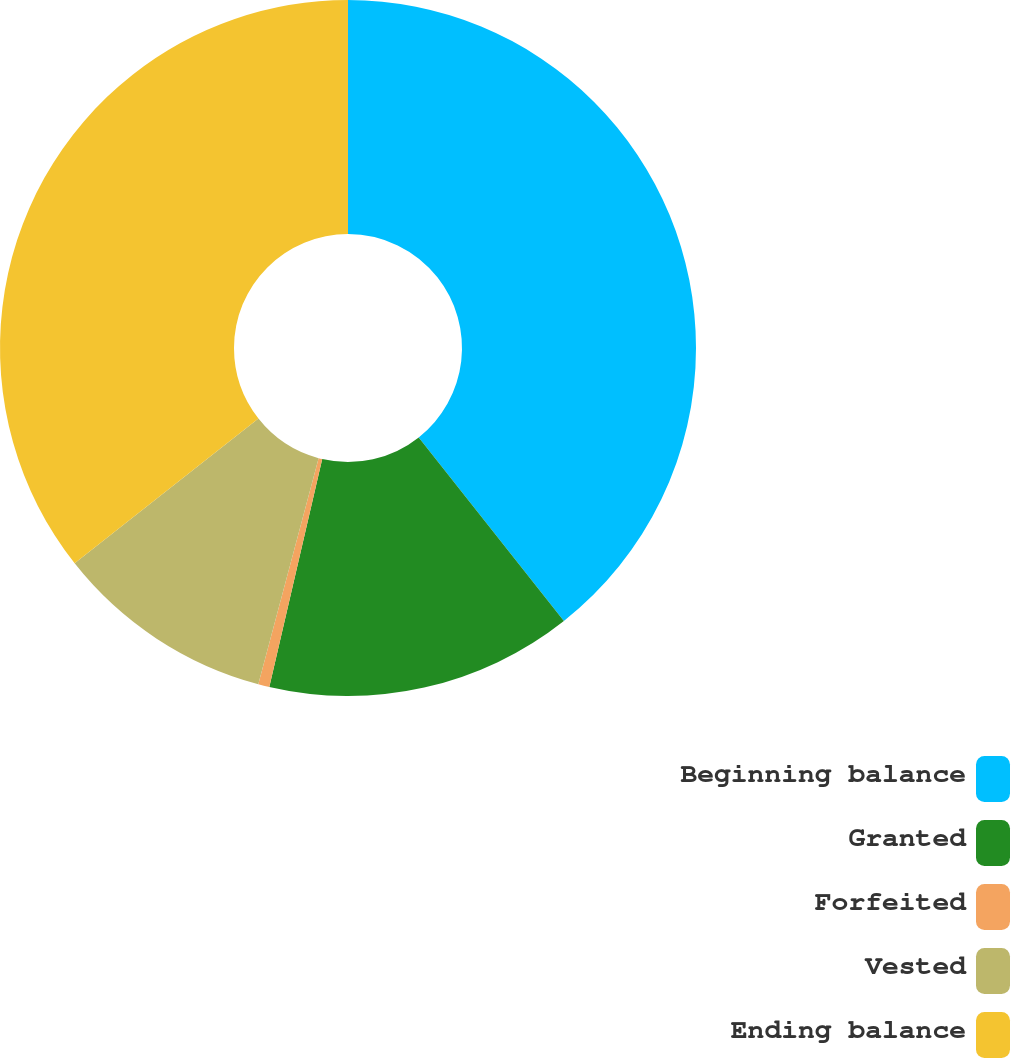Convert chart to OTSL. <chart><loc_0><loc_0><loc_500><loc_500><pie_chart><fcel>Beginning balance<fcel>Granted<fcel>Forfeited<fcel>Vested<fcel>Ending balance<nl><fcel>39.35%<fcel>14.28%<fcel>0.52%<fcel>10.23%<fcel>35.62%<nl></chart> 